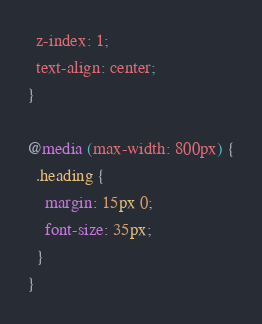<code> <loc_0><loc_0><loc_500><loc_500><_CSS_>  z-index: 1;
  text-align: center;
}

@media (max-width: 800px) {
  .heading {
    margin: 15px 0;
    font-size: 35px;
  }
}
</code> 